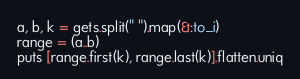<code> <loc_0><loc_0><loc_500><loc_500><_Ruby_>a, b, k = gets.split(" ").map(&:to_i)
range = (a..b)
puts [range.first(k), range.last(k)].flatten.uniq
</code> 